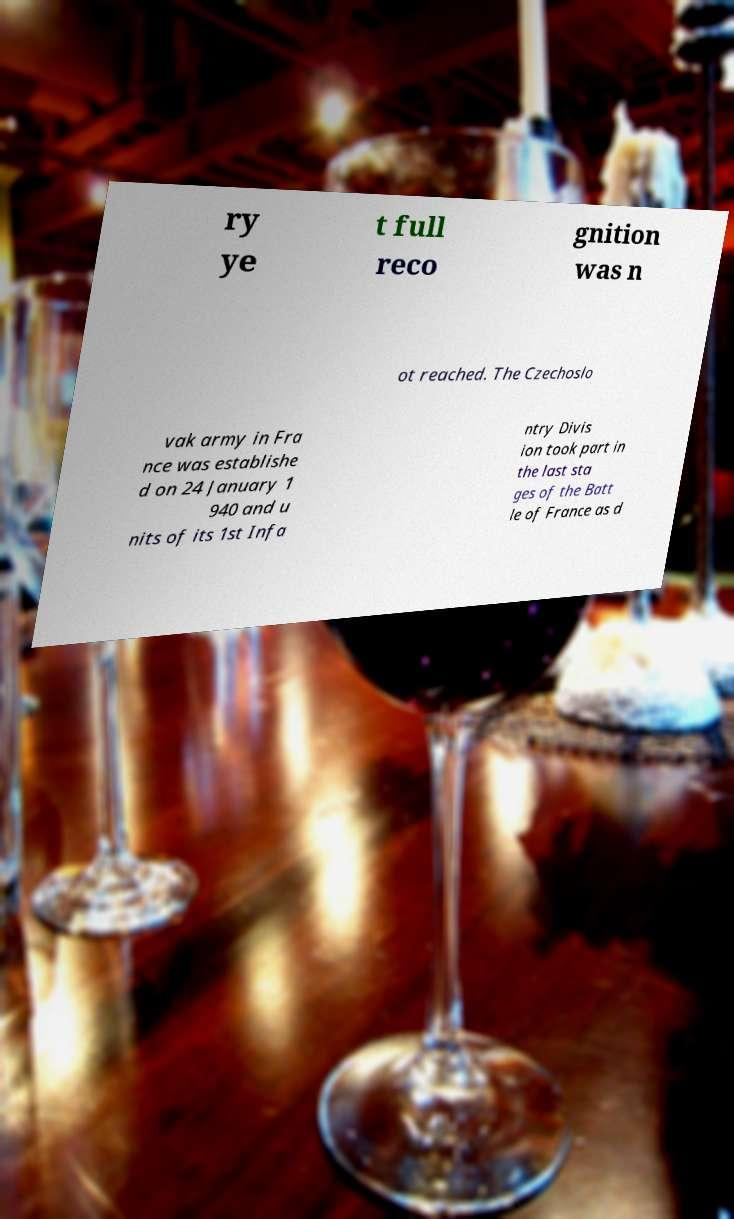Please read and relay the text visible in this image. What does it say? ry ye t full reco gnition was n ot reached. The Czechoslo vak army in Fra nce was establishe d on 24 January 1 940 and u nits of its 1st Infa ntry Divis ion took part in the last sta ges of the Batt le of France as d 